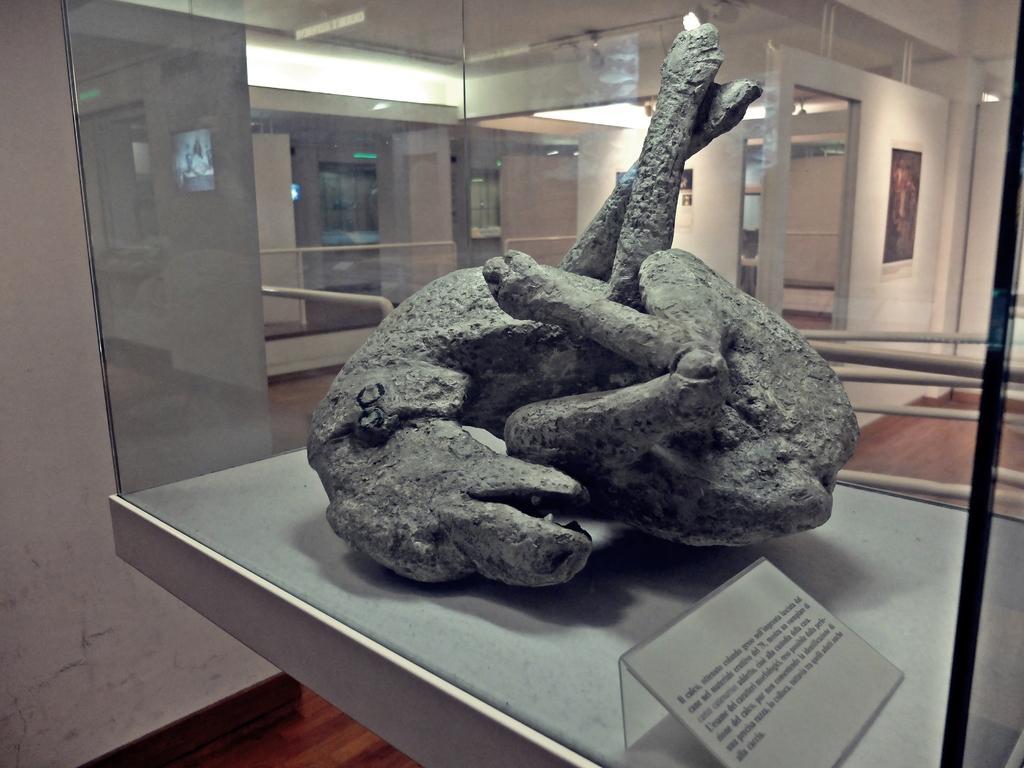Describe this image in one or two sentences. In this image I can see a animal sculpture kept on glass box, there is the wall, doors, photo frame attached to the wall visible in the middle. 